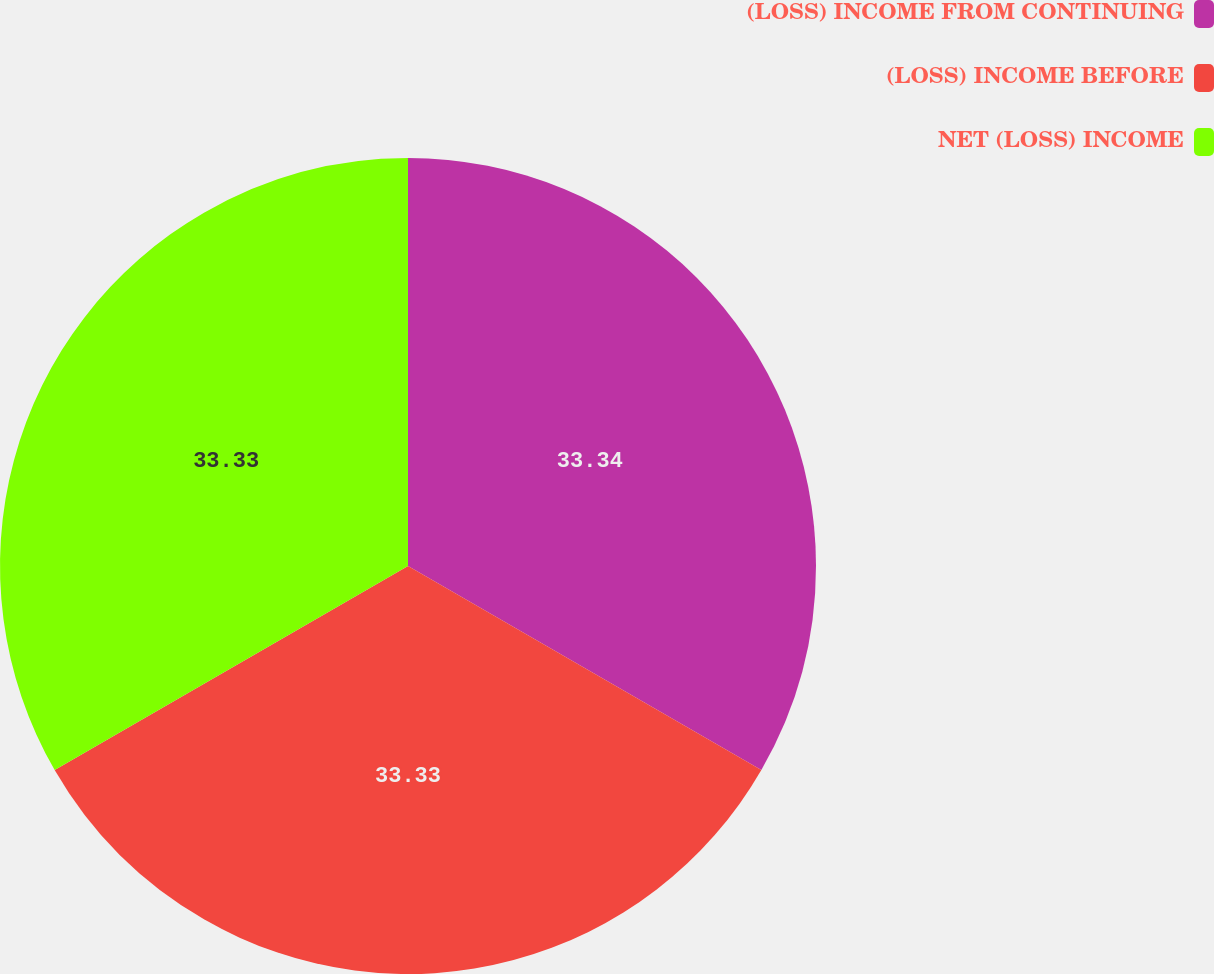Convert chart to OTSL. <chart><loc_0><loc_0><loc_500><loc_500><pie_chart><fcel>(LOSS) INCOME FROM CONTINUING<fcel>(LOSS) INCOME BEFORE<fcel>NET (LOSS) INCOME<nl><fcel>33.33%<fcel>33.33%<fcel>33.33%<nl></chart> 